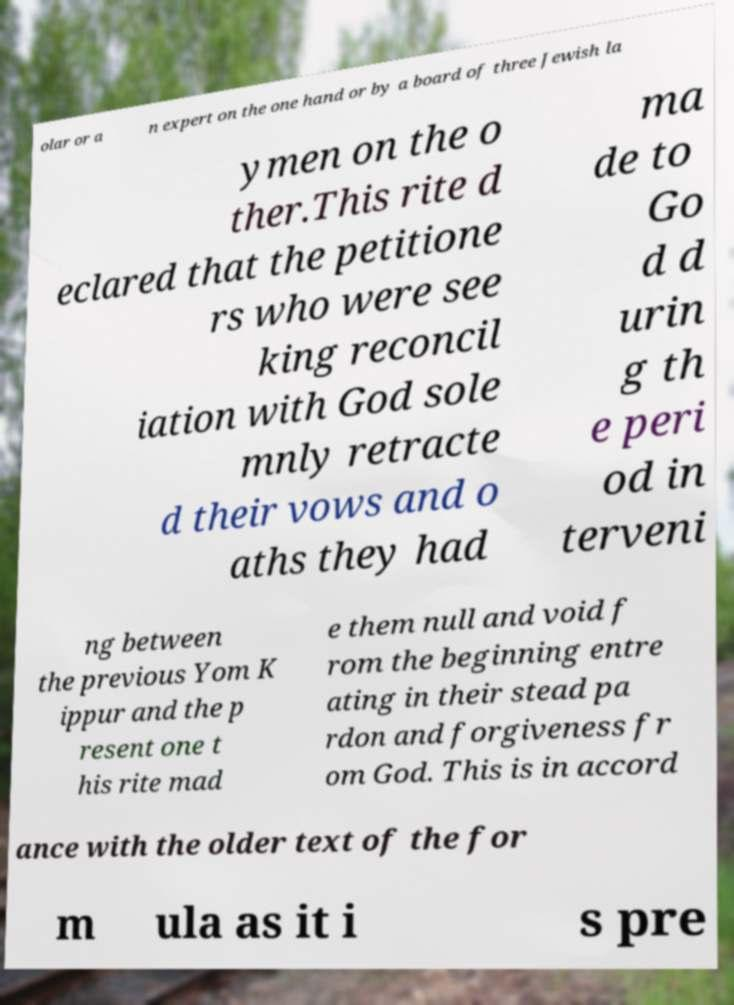For documentation purposes, I need the text within this image transcribed. Could you provide that? olar or a n expert on the one hand or by a board of three Jewish la ymen on the o ther.This rite d eclared that the petitione rs who were see king reconcil iation with God sole mnly retracte d their vows and o aths they had ma de to Go d d urin g th e peri od in terveni ng between the previous Yom K ippur and the p resent one t his rite mad e them null and void f rom the beginning entre ating in their stead pa rdon and forgiveness fr om God. This is in accord ance with the older text of the for m ula as it i s pre 